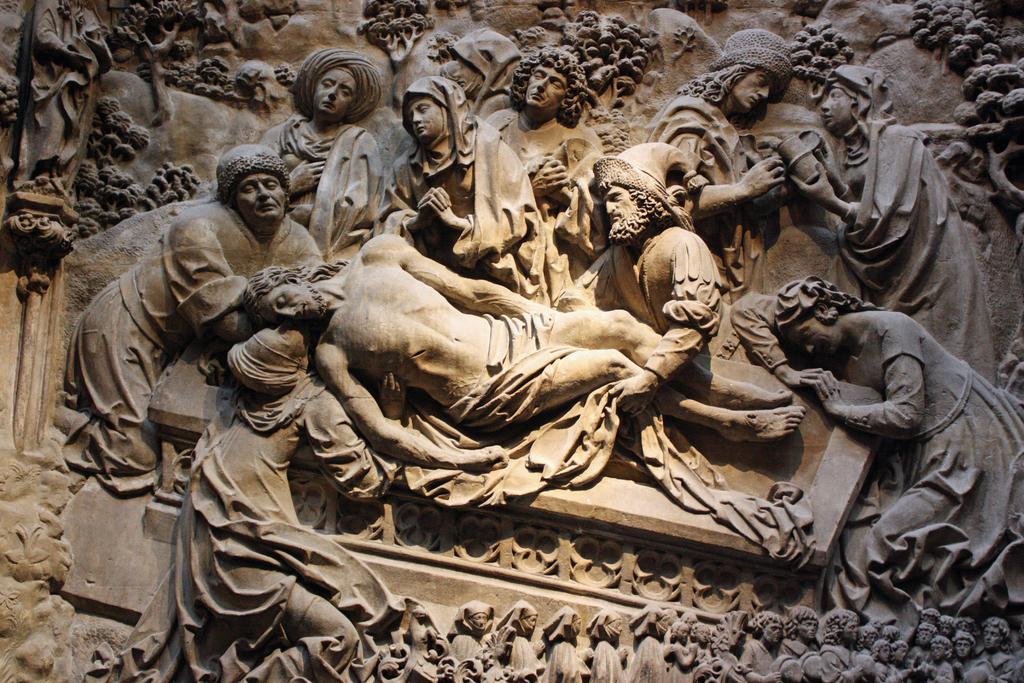How would you summarize this image in a sentence or two? In this image we can see sculptures carved on the wall. 